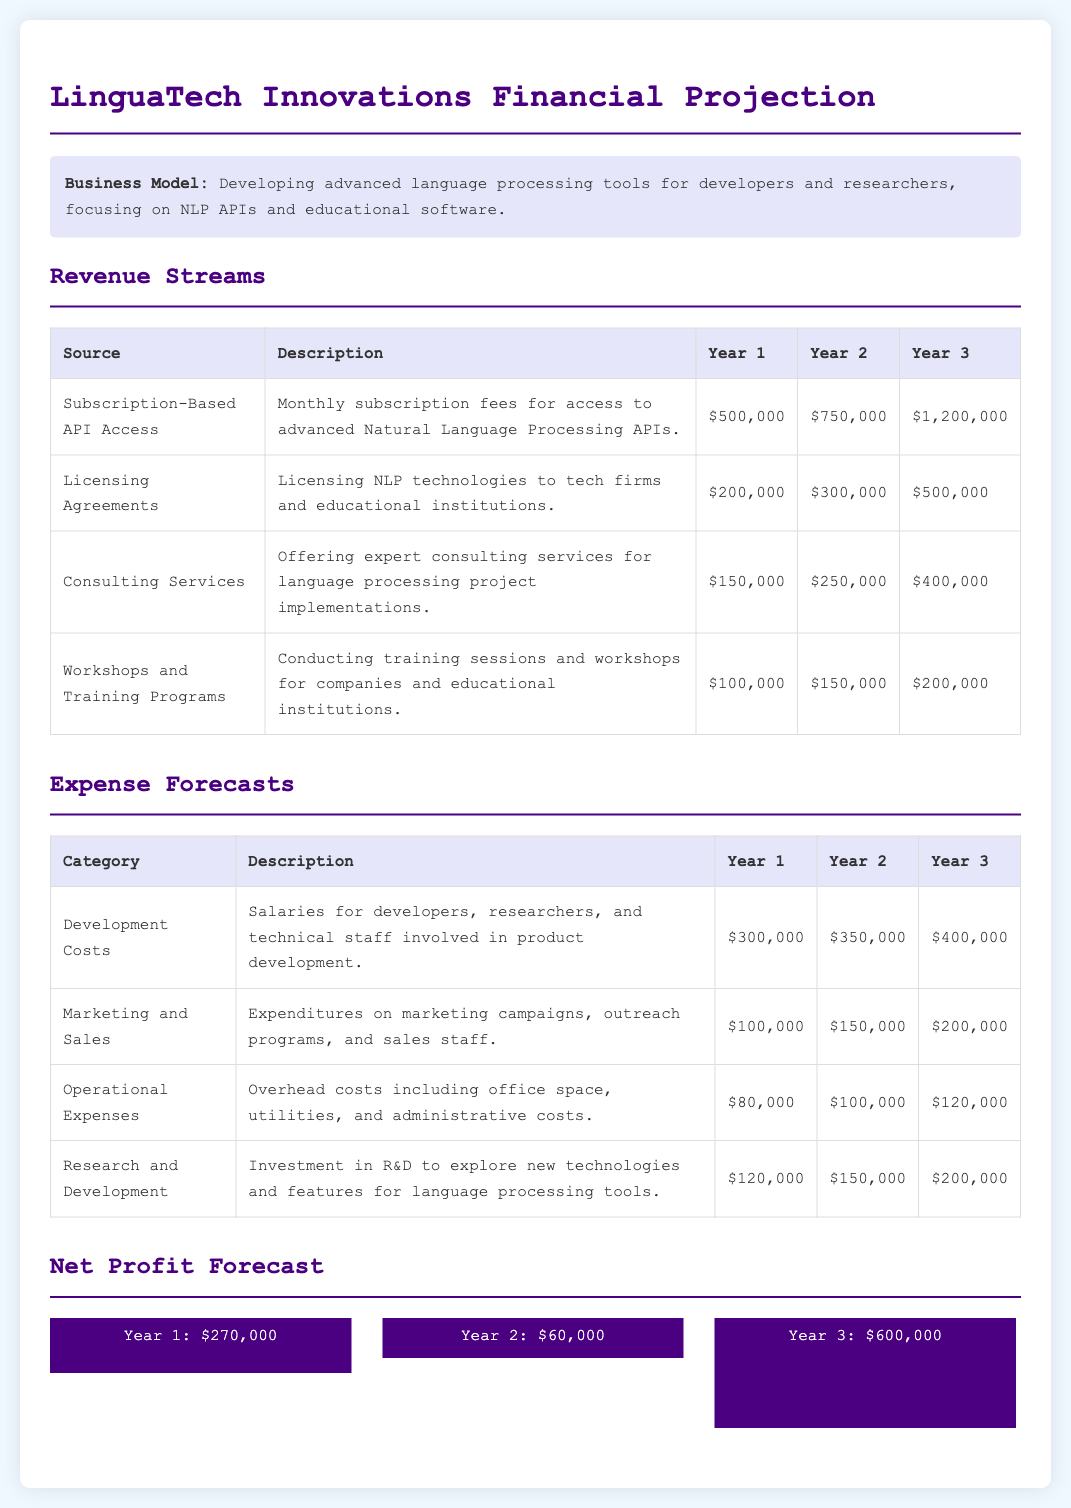what is the total revenue in Year 1? The total revenue in Year 1 is the sum of all revenue sources: $500,000 + $200,000 + $150,000 + $100,000 = $950,000.
Answer: $950,000 what is the projected revenue from Subscription-Based API Access in Year 3? The projected revenue from Subscription-Based API Access in Year 3 is directly stated in the document as $1,200,000.
Answer: $1,200,000 how much does LinguaTech Innovations anticipate to spend on Research and Development in Year 2? The spending on Research and Development in Year 2 is listed as $150,000 in the expense forecasts table.
Answer: $150,000 what is the net profit for Year 1? The net profit for Year 1 is calculated by subtracting total expenses from total revenue, which is $950,000 - ($300,000 + $100,000 + $80,000 + $120,000) = $270,000.
Answer: $270,000 which category has the highest forecasted expense in Year 3? The category with the highest forecasted expense in Year 3 is Development Costs at $400,000.
Answer: Development Costs what is the increase in revenue from Workshops and Training Programs from Year 1 to Year 3? The increase in revenue from Workshops and Training Programs is $200,000 - $100,000 = $100,000.
Answer: $100,000 how much is the total operational expense forecasted for Year 1? The total operational expenses in Year 1 are listed as $80,000.
Answer: $80,000 what is the business model focus of LinguaTech Innovations? The business model focus is on developing advanced language processing tools for developers and researchers.
Answer: Advanced language processing tools what is the revenue from Licensing Agreements in Year 2? The revenue from Licensing Agreements in Year 2 is clearly stated as $300,000.
Answer: $300,000 